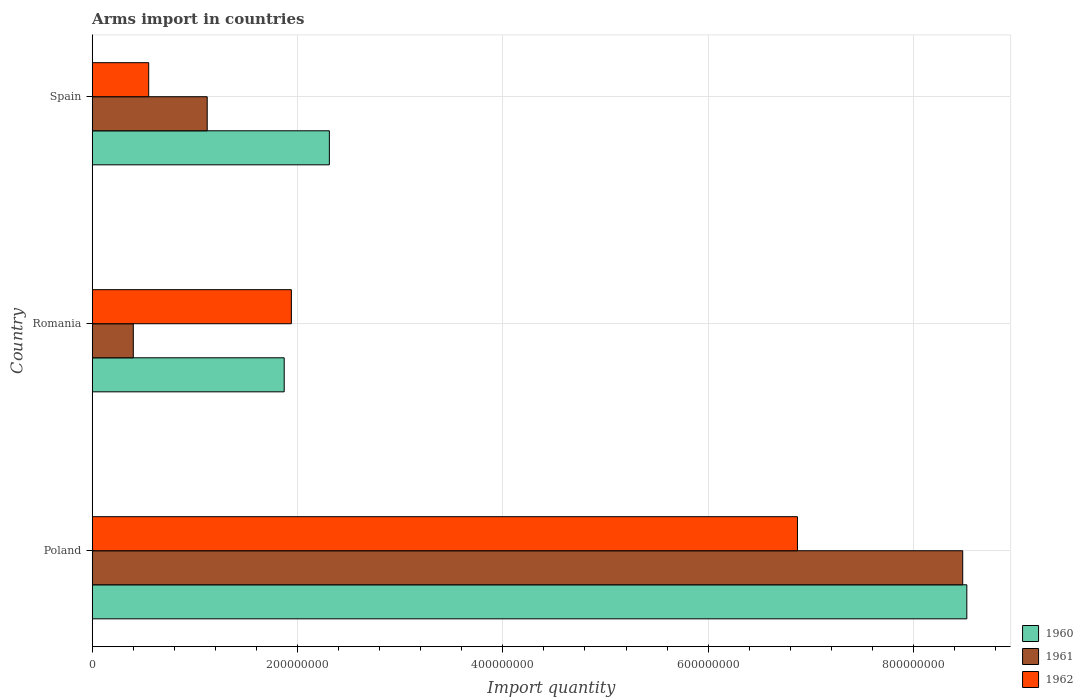How many different coloured bars are there?
Provide a short and direct response. 3. Are the number of bars per tick equal to the number of legend labels?
Ensure brevity in your answer.  Yes. Are the number of bars on each tick of the Y-axis equal?
Offer a very short reply. Yes. In how many cases, is the number of bars for a given country not equal to the number of legend labels?
Provide a short and direct response. 0. What is the total arms import in 1961 in Spain?
Ensure brevity in your answer.  1.12e+08. Across all countries, what is the maximum total arms import in 1962?
Your answer should be compact. 6.87e+08. Across all countries, what is the minimum total arms import in 1961?
Keep it short and to the point. 4.00e+07. In which country was the total arms import in 1962 minimum?
Offer a terse response. Spain. What is the total total arms import in 1962 in the graph?
Your answer should be very brief. 9.36e+08. What is the difference between the total arms import in 1960 in Romania and that in Spain?
Your answer should be very brief. -4.40e+07. What is the difference between the total arms import in 1962 in Poland and the total arms import in 1960 in Romania?
Ensure brevity in your answer.  5.00e+08. What is the average total arms import in 1961 per country?
Offer a terse response. 3.33e+08. What is the difference between the total arms import in 1962 and total arms import in 1960 in Spain?
Your answer should be very brief. -1.76e+08. In how many countries, is the total arms import in 1961 greater than 280000000 ?
Keep it short and to the point. 1. What is the ratio of the total arms import in 1962 in Romania to that in Spain?
Provide a short and direct response. 3.53. Is the difference between the total arms import in 1962 in Poland and Spain greater than the difference between the total arms import in 1960 in Poland and Spain?
Keep it short and to the point. Yes. What is the difference between the highest and the second highest total arms import in 1962?
Keep it short and to the point. 4.93e+08. What is the difference between the highest and the lowest total arms import in 1961?
Your answer should be very brief. 8.08e+08. In how many countries, is the total arms import in 1960 greater than the average total arms import in 1960 taken over all countries?
Give a very brief answer. 1. Is it the case that in every country, the sum of the total arms import in 1960 and total arms import in 1962 is greater than the total arms import in 1961?
Your answer should be compact. Yes. How many bars are there?
Your response must be concise. 9. Are all the bars in the graph horizontal?
Keep it short and to the point. Yes. What is the difference between two consecutive major ticks on the X-axis?
Make the answer very short. 2.00e+08. Does the graph contain any zero values?
Provide a succinct answer. No. Does the graph contain grids?
Your response must be concise. Yes. Where does the legend appear in the graph?
Your answer should be very brief. Bottom right. What is the title of the graph?
Make the answer very short. Arms import in countries. Does "2015" appear as one of the legend labels in the graph?
Your answer should be compact. No. What is the label or title of the X-axis?
Make the answer very short. Import quantity. What is the Import quantity in 1960 in Poland?
Provide a short and direct response. 8.52e+08. What is the Import quantity in 1961 in Poland?
Ensure brevity in your answer.  8.48e+08. What is the Import quantity of 1962 in Poland?
Your answer should be very brief. 6.87e+08. What is the Import quantity in 1960 in Romania?
Ensure brevity in your answer.  1.87e+08. What is the Import quantity in 1961 in Romania?
Your answer should be very brief. 4.00e+07. What is the Import quantity in 1962 in Romania?
Provide a short and direct response. 1.94e+08. What is the Import quantity in 1960 in Spain?
Your response must be concise. 2.31e+08. What is the Import quantity of 1961 in Spain?
Offer a terse response. 1.12e+08. What is the Import quantity of 1962 in Spain?
Make the answer very short. 5.50e+07. Across all countries, what is the maximum Import quantity of 1960?
Offer a terse response. 8.52e+08. Across all countries, what is the maximum Import quantity in 1961?
Provide a succinct answer. 8.48e+08. Across all countries, what is the maximum Import quantity of 1962?
Keep it short and to the point. 6.87e+08. Across all countries, what is the minimum Import quantity of 1960?
Your answer should be compact. 1.87e+08. Across all countries, what is the minimum Import quantity in 1961?
Make the answer very short. 4.00e+07. Across all countries, what is the minimum Import quantity of 1962?
Give a very brief answer. 5.50e+07. What is the total Import quantity in 1960 in the graph?
Give a very brief answer. 1.27e+09. What is the total Import quantity of 1962 in the graph?
Your response must be concise. 9.36e+08. What is the difference between the Import quantity of 1960 in Poland and that in Romania?
Keep it short and to the point. 6.65e+08. What is the difference between the Import quantity in 1961 in Poland and that in Romania?
Make the answer very short. 8.08e+08. What is the difference between the Import quantity in 1962 in Poland and that in Romania?
Offer a very short reply. 4.93e+08. What is the difference between the Import quantity of 1960 in Poland and that in Spain?
Your answer should be very brief. 6.21e+08. What is the difference between the Import quantity in 1961 in Poland and that in Spain?
Your answer should be compact. 7.36e+08. What is the difference between the Import quantity in 1962 in Poland and that in Spain?
Provide a short and direct response. 6.32e+08. What is the difference between the Import quantity in 1960 in Romania and that in Spain?
Provide a succinct answer. -4.40e+07. What is the difference between the Import quantity in 1961 in Romania and that in Spain?
Your answer should be very brief. -7.20e+07. What is the difference between the Import quantity in 1962 in Romania and that in Spain?
Ensure brevity in your answer.  1.39e+08. What is the difference between the Import quantity in 1960 in Poland and the Import quantity in 1961 in Romania?
Ensure brevity in your answer.  8.12e+08. What is the difference between the Import quantity of 1960 in Poland and the Import quantity of 1962 in Romania?
Provide a short and direct response. 6.58e+08. What is the difference between the Import quantity of 1961 in Poland and the Import quantity of 1962 in Romania?
Your answer should be very brief. 6.54e+08. What is the difference between the Import quantity in 1960 in Poland and the Import quantity in 1961 in Spain?
Give a very brief answer. 7.40e+08. What is the difference between the Import quantity of 1960 in Poland and the Import quantity of 1962 in Spain?
Provide a short and direct response. 7.97e+08. What is the difference between the Import quantity in 1961 in Poland and the Import quantity in 1962 in Spain?
Give a very brief answer. 7.93e+08. What is the difference between the Import quantity of 1960 in Romania and the Import quantity of 1961 in Spain?
Provide a short and direct response. 7.50e+07. What is the difference between the Import quantity in 1960 in Romania and the Import quantity in 1962 in Spain?
Provide a succinct answer. 1.32e+08. What is the difference between the Import quantity of 1961 in Romania and the Import quantity of 1962 in Spain?
Keep it short and to the point. -1.50e+07. What is the average Import quantity in 1960 per country?
Give a very brief answer. 4.23e+08. What is the average Import quantity in 1961 per country?
Ensure brevity in your answer.  3.33e+08. What is the average Import quantity of 1962 per country?
Your answer should be compact. 3.12e+08. What is the difference between the Import quantity of 1960 and Import quantity of 1961 in Poland?
Offer a terse response. 4.00e+06. What is the difference between the Import quantity in 1960 and Import quantity in 1962 in Poland?
Offer a terse response. 1.65e+08. What is the difference between the Import quantity in 1961 and Import quantity in 1962 in Poland?
Ensure brevity in your answer.  1.61e+08. What is the difference between the Import quantity of 1960 and Import quantity of 1961 in Romania?
Keep it short and to the point. 1.47e+08. What is the difference between the Import quantity in 1960 and Import quantity in 1962 in Romania?
Ensure brevity in your answer.  -7.00e+06. What is the difference between the Import quantity in 1961 and Import quantity in 1962 in Romania?
Your answer should be very brief. -1.54e+08. What is the difference between the Import quantity in 1960 and Import quantity in 1961 in Spain?
Give a very brief answer. 1.19e+08. What is the difference between the Import quantity in 1960 and Import quantity in 1962 in Spain?
Make the answer very short. 1.76e+08. What is the difference between the Import quantity in 1961 and Import quantity in 1962 in Spain?
Provide a succinct answer. 5.70e+07. What is the ratio of the Import quantity of 1960 in Poland to that in Romania?
Keep it short and to the point. 4.56. What is the ratio of the Import quantity in 1961 in Poland to that in Romania?
Make the answer very short. 21.2. What is the ratio of the Import quantity of 1962 in Poland to that in Romania?
Offer a terse response. 3.54. What is the ratio of the Import quantity in 1960 in Poland to that in Spain?
Ensure brevity in your answer.  3.69. What is the ratio of the Import quantity of 1961 in Poland to that in Spain?
Give a very brief answer. 7.57. What is the ratio of the Import quantity in 1962 in Poland to that in Spain?
Keep it short and to the point. 12.49. What is the ratio of the Import quantity in 1960 in Romania to that in Spain?
Offer a terse response. 0.81. What is the ratio of the Import quantity of 1961 in Romania to that in Spain?
Ensure brevity in your answer.  0.36. What is the ratio of the Import quantity of 1962 in Romania to that in Spain?
Provide a succinct answer. 3.53. What is the difference between the highest and the second highest Import quantity in 1960?
Your answer should be compact. 6.21e+08. What is the difference between the highest and the second highest Import quantity in 1961?
Make the answer very short. 7.36e+08. What is the difference between the highest and the second highest Import quantity of 1962?
Ensure brevity in your answer.  4.93e+08. What is the difference between the highest and the lowest Import quantity in 1960?
Your answer should be compact. 6.65e+08. What is the difference between the highest and the lowest Import quantity in 1961?
Make the answer very short. 8.08e+08. What is the difference between the highest and the lowest Import quantity in 1962?
Provide a short and direct response. 6.32e+08. 